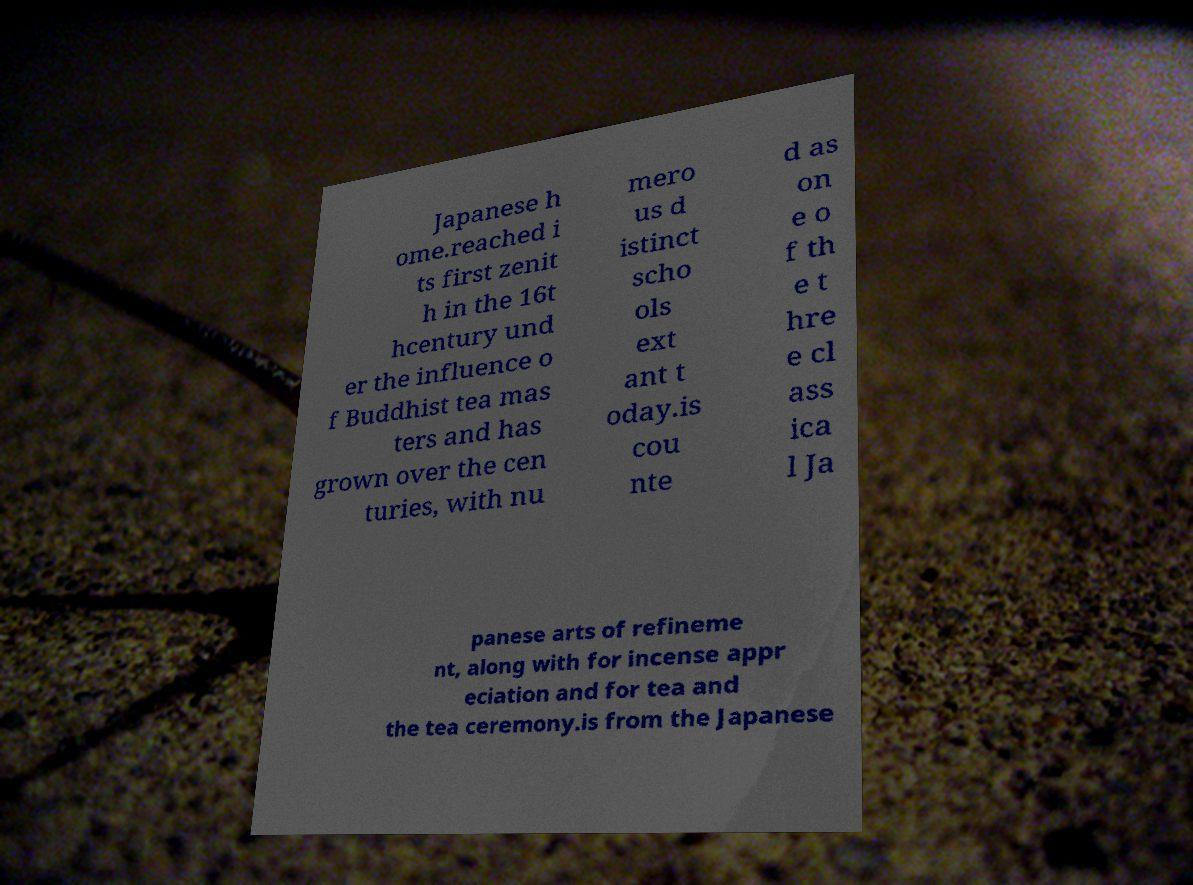Can you accurately transcribe the text from the provided image for me? Japanese h ome.reached i ts first zenit h in the 16t hcentury und er the influence o f Buddhist tea mas ters and has grown over the cen turies, with nu mero us d istinct scho ols ext ant t oday.is cou nte d as on e o f th e t hre e cl ass ica l Ja panese arts of refineme nt, along with for incense appr eciation and for tea and the tea ceremony.is from the Japanese 